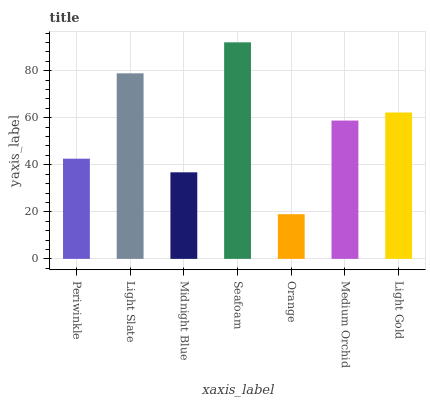Is Orange the minimum?
Answer yes or no. Yes. Is Seafoam the maximum?
Answer yes or no. Yes. Is Light Slate the minimum?
Answer yes or no. No. Is Light Slate the maximum?
Answer yes or no. No. Is Light Slate greater than Periwinkle?
Answer yes or no. Yes. Is Periwinkle less than Light Slate?
Answer yes or no. Yes. Is Periwinkle greater than Light Slate?
Answer yes or no. No. Is Light Slate less than Periwinkle?
Answer yes or no. No. Is Medium Orchid the high median?
Answer yes or no. Yes. Is Medium Orchid the low median?
Answer yes or no. Yes. Is Periwinkle the high median?
Answer yes or no. No. Is Light Gold the low median?
Answer yes or no. No. 